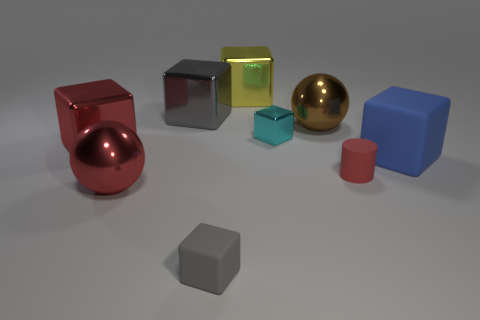Are there any big yellow shiny cylinders?
Keep it short and to the point. No. What shape is the tiny rubber thing behind the matte cube that is in front of the tiny thing right of the brown metallic ball?
Offer a terse response. Cylinder. What number of blue things are on the right side of the large gray object?
Provide a short and direct response. 1. Does the big block that is behind the gray metallic block have the same material as the tiny cyan thing?
Give a very brief answer. Yes. What number of other objects are there of the same shape as the large brown metallic object?
Your response must be concise. 1. There is a gray cube behind the sphere in front of the tiny red cylinder; how many large blue rubber blocks are in front of it?
Keep it short and to the point. 1. What color is the shiny block to the left of the large gray thing?
Keep it short and to the point. Red. There is a metal sphere on the left side of the yellow block; is its color the same as the cylinder?
Offer a very short reply. Yes. What is the size of the red thing that is the same shape as the yellow thing?
Give a very brief answer. Large. The ball that is in front of the cube to the left of the big red object that is to the right of the red metallic block is made of what material?
Give a very brief answer. Metal. 